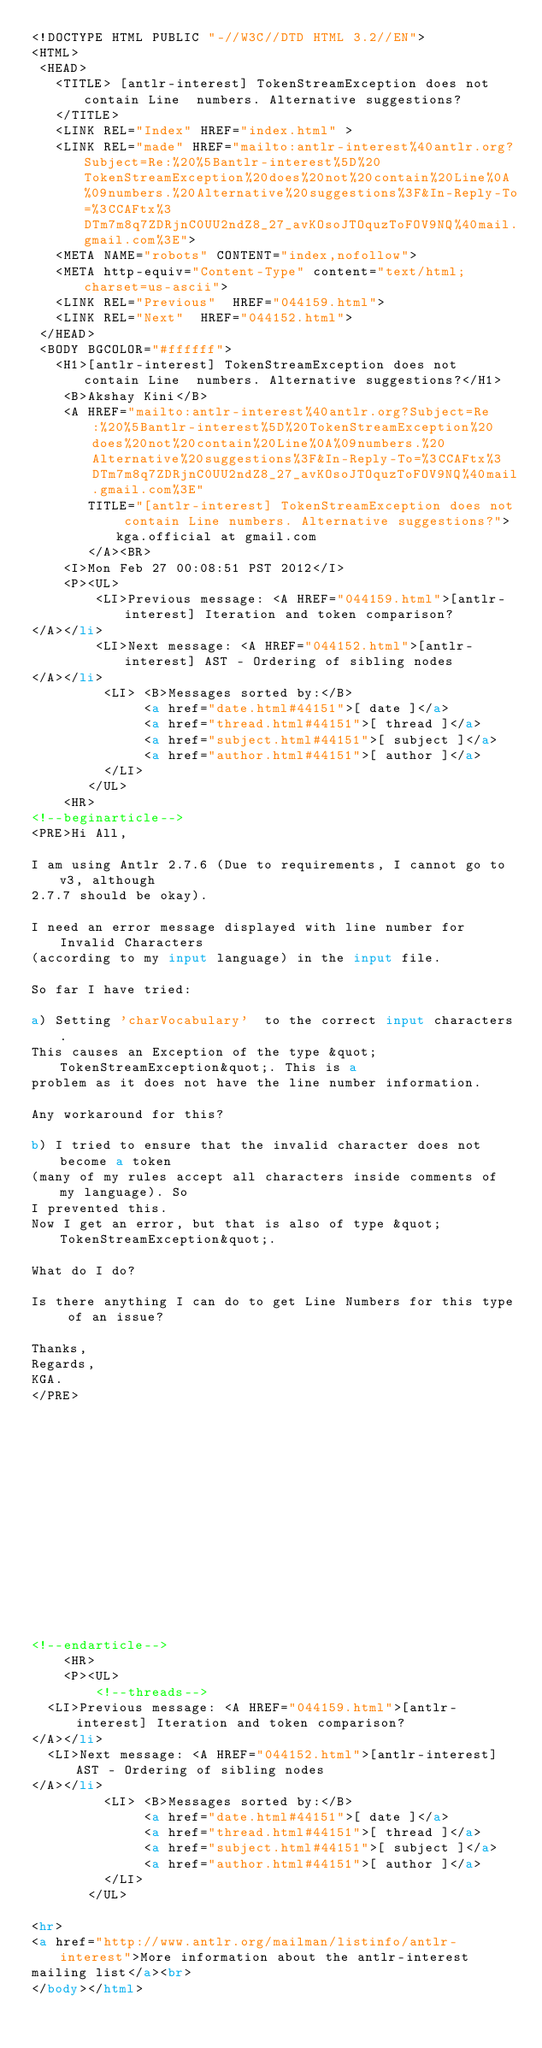Convert code to text. <code><loc_0><loc_0><loc_500><loc_500><_HTML_><!DOCTYPE HTML PUBLIC "-//W3C//DTD HTML 3.2//EN">
<HTML>
 <HEAD>
   <TITLE> [antlr-interest] TokenStreamException does not contain Line	numbers. Alternative suggestions?
   </TITLE>
   <LINK REL="Index" HREF="index.html" >
   <LINK REL="made" HREF="mailto:antlr-interest%40antlr.org?Subject=Re:%20%5Bantlr-interest%5D%20TokenStreamException%20does%20not%20contain%20Line%0A%09numbers.%20Alternative%20suggestions%3F&In-Reply-To=%3CCAFtx%3DTm7m8q7ZDRjnC0UU2ndZ8_27_avKOsoJTOquzToFOV9NQ%40mail.gmail.com%3E">
   <META NAME="robots" CONTENT="index,nofollow">
   <META http-equiv="Content-Type" content="text/html; charset=us-ascii">
   <LINK REL="Previous"  HREF="044159.html">
   <LINK REL="Next"  HREF="044152.html">
 </HEAD>
 <BODY BGCOLOR="#ffffff">
   <H1>[antlr-interest] TokenStreamException does not contain Line	numbers. Alternative suggestions?</H1>
    <B>Akshay Kini</B> 
    <A HREF="mailto:antlr-interest%40antlr.org?Subject=Re:%20%5Bantlr-interest%5D%20TokenStreamException%20does%20not%20contain%20Line%0A%09numbers.%20Alternative%20suggestions%3F&In-Reply-To=%3CCAFtx%3DTm7m8q7ZDRjnC0UU2ndZ8_27_avKOsoJTOquzToFOV9NQ%40mail.gmail.com%3E"
       TITLE="[antlr-interest] TokenStreamException does not contain Line	numbers. Alternative suggestions?">kga.official at gmail.com
       </A><BR>
    <I>Mon Feb 27 00:08:51 PST 2012</I>
    <P><UL>
        <LI>Previous message: <A HREF="044159.html">[antlr-interest] Iteration and token comparison?
</A></li>
        <LI>Next message: <A HREF="044152.html">[antlr-interest] AST - Ordering of sibling nodes
</A></li>
         <LI> <B>Messages sorted by:</B> 
              <a href="date.html#44151">[ date ]</a>
              <a href="thread.html#44151">[ thread ]</a>
              <a href="subject.html#44151">[ subject ]</a>
              <a href="author.html#44151">[ author ]</a>
         </LI>
       </UL>
    <HR>  
<!--beginarticle-->
<PRE>Hi All,

I am using Antlr 2.7.6 (Due to requirements, I cannot go to v3, although
2.7.7 should be okay).

I need an error message displayed with line number for Invalid Characters
(according to my input language) in the input file.

So far I have tried:

a) Setting 'charVocabulary'  to the correct input characters.
This causes an Exception of the type &quot;TokenStreamException&quot;. This is a
problem as it does not have the line number information.

Any workaround for this?

b) I tried to ensure that the invalid character does not become a token
(many of my rules accept all characters inside comments of my language). So
I prevented this.
Now I get an error, but that is also of type &quot;TokenStreamException&quot;.

What do I do?

Is there anything I can do to get Line Numbers for this type of an issue?

Thanks,
Regards,
KGA.
</PRE>















<!--endarticle-->
    <HR>
    <P><UL>
        <!--threads-->
	<LI>Previous message: <A HREF="044159.html">[antlr-interest] Iteration and token comparison?
</A></li>
	<LI>Next message: <A HREF="044152.html">[antlr-interest] AST - Ordering of sibling nodes
</A></li>
         <LI> <B>Messages sorted by:</B> 
              <a href="date.html#44151">[ date ]</a>
              <a href="thread.html#44151">[ thread ]</a>
              <a href="subject.html#44151">[ subject ]</a>
              <a href="author.html#44151">[ author ]</a>
         </LI>
       </UL>

<hr>
<a href="http://www.antlr.org/mailman/listinfo/antlr-interest">More information about the antlr-interest
mailing list</a><br>
</body></html>
</code> 